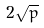<formula> <loc_0><loc_0><loc_500><loc_500>2 \sqrt { p }</formula> 